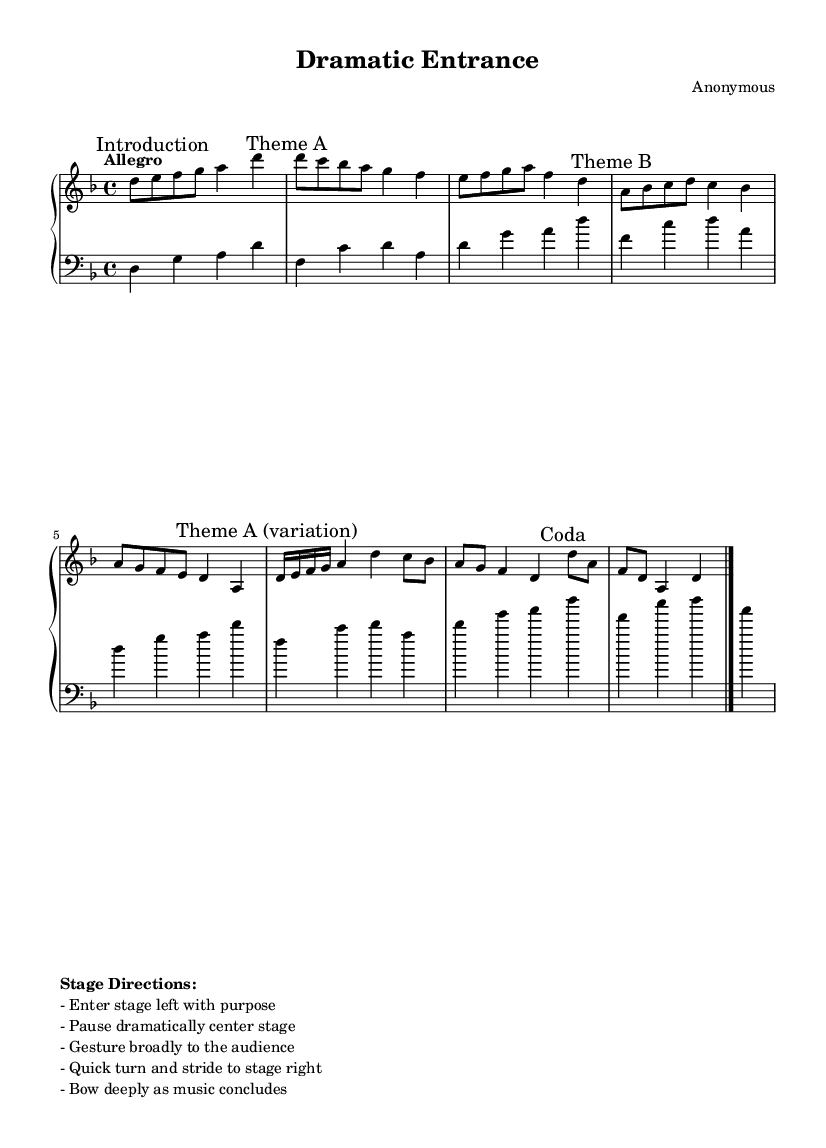What is the key signature of this music? The key signature is indicated by 'd minor,' which shows one flat on the staff. The presence of the flat indicates that the piece is based in the D minor scale.
Answer: D minor What is the time signature of this piece? The time signature is displayed at the beginning of the score, which is '4/4,' meaning there are four beats in each measure.
Answer: 4/4 What is the tempo marking for this composition? The tempo is marked as "Allegro," suggesting a fast and lively pace. The word is directly placed in the score near the beginning.
Answer: Allegro What is the first marked section in the music? The first marked section is labeled "Introduction," found at the beginning of the right-hand part before any thematic material starts.
Answer: Introduction How many themes are there in this composition? Upon examining the marked sections, there are two primary themes labeled as "Theme A" and "Theme B," and one variation of "Theme A." Therefore, we count three thematic sections in total.
Answer: Three What action is indicated in the stage directions related to pausing? One of the stage directions specifies "Pause dramatically center stage," indicating a key moment in the performance that aligns with the music's dynamics.
Answer: Pause dramatically center stage What is indicated by the 'Coda' section in this composition? The 'Coda' section signifies the concluding part of the music. It is explicitly marked in the score and usually signals the wrap-up of the composition after earlier themes have been developed.
Answer: Coda 